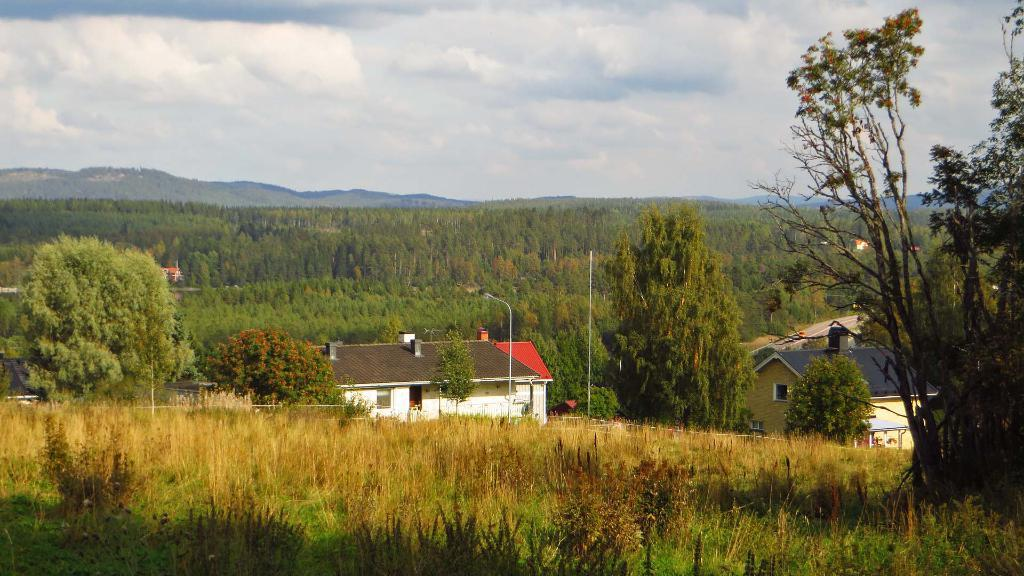What is located in the center of the image? There are seeds and trees in the center of the image. What structures can be seen in the image? Poles are visible in the image. What type of vegetation is at the bottom of the image? There is grass at the bottom of the image. What can be seen in the background of the image? There are hills and the sky visible in the background of the image. What type of trousers are the trees wearing in the image? Trees do not wear trousers, as they are not human or capable of wearing clothing. 